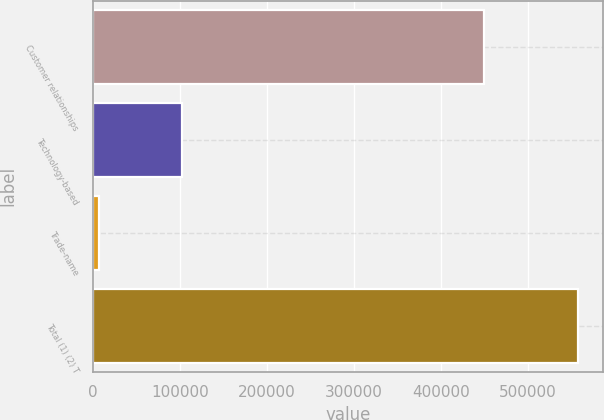Convert chart to OTSL. <chart><loc_0><loc_0><loc_500><loc_500><bar_chart><fcel>Customer relationships<fcel>Technology-based<fcel>Trade-name<fcel>Total (1) (2) T<nl><fcel>449369<fcel>101920<fcel>6906<fcel>558395<nl></chart> 